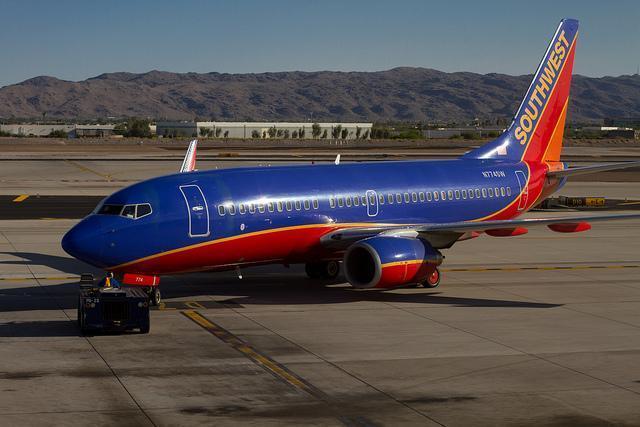How many planes are there?
Give a very brief answer. 1. 